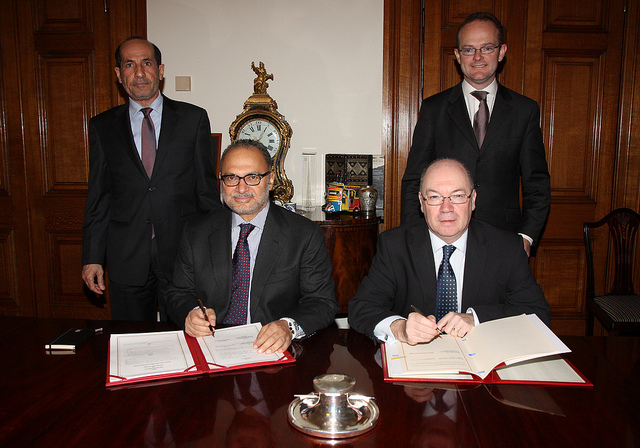What type of event is this?
A. funeral
B. shower
C. wedding
D. meeting Based on the image, where multiple individuals appear formally dressed and seated at a table with documents in front of them, it indicates a formal gathering, most likely a professional meeting or event. So the answer D, 'meeting,' suggested by the model, is the most accurate among the provided options. 